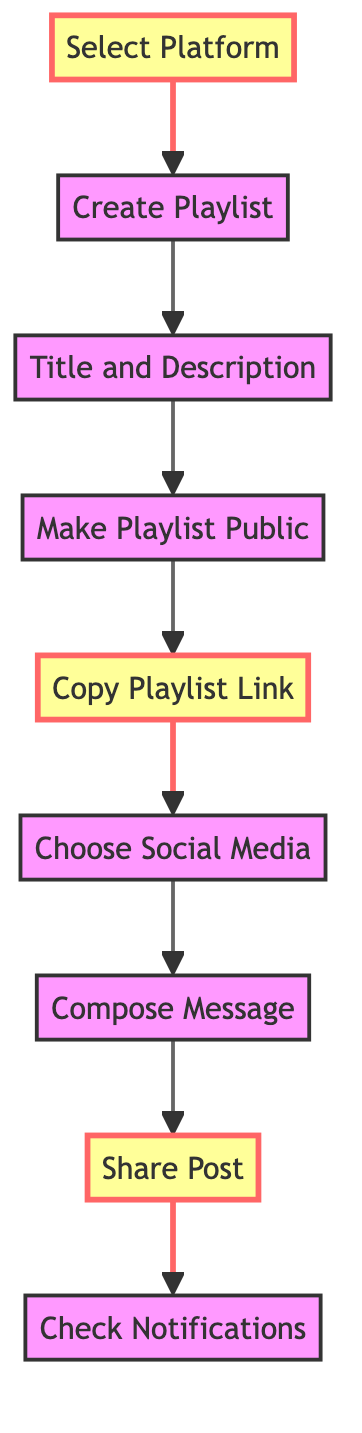What is the first step in the diagram? The first step is indicated as "Select Platform", which is the initial action you need to take. This is the starting point of the flowchart.
Answer: Select Platform How many steps are there in total? By counting all the listed steps in the diagram from "Select Platform" to "Check Notifications", there are nine identifiable actions or steps in the flow.
Answer: Nine Which step comes after "Copy Playlist Link"? Following the "Copy Playlist Link", the next action listed is "Choose Social Media", which directly connects to the previous step in the flow.
Answer: Choose Social Media What is the last step in the instruction flow? The final step is "Check Notifications", which signifies the end of the process after sharing the playlist.
Answer: Check Notifications What should you do before sharing the post? You need to "Compose Message" before you can "Share Post", as it serves as a precursor by preparing the accompanying content for the social media share.
Answer: Compose Message How many steps need to be completed before copying the playlist link? To reach the "Copy Playlist Link" step, four previous actions need to be completed: "Select Platform", "Create Playlist", "Title and Description", and "Make Playlist Public".
Answer: Four Which steps are highlighted in the diagram? The highlighted steps are "Select Platform", "Copy Playlist Link", and "Share Post", distinguished visually to emphasize their importance in the flow process.
Answer: Select Platform, Copy Playlist Link, Share Post What is the relationship between "Make Playlist Public" and "Copy Playlist Link"? "Make Playlist Public" is a prerequisite step for "Copy Playlist Link," meaning you must ensure the playlist is public before you can generate a shareable link.
Answer: Prerequisite What message do you write after choosing the social media platform? After "Choose Social Media", you need to "Compose Message", which involves writing an encouraging message to share alongside the playlist link.
Answer: Compose Message 